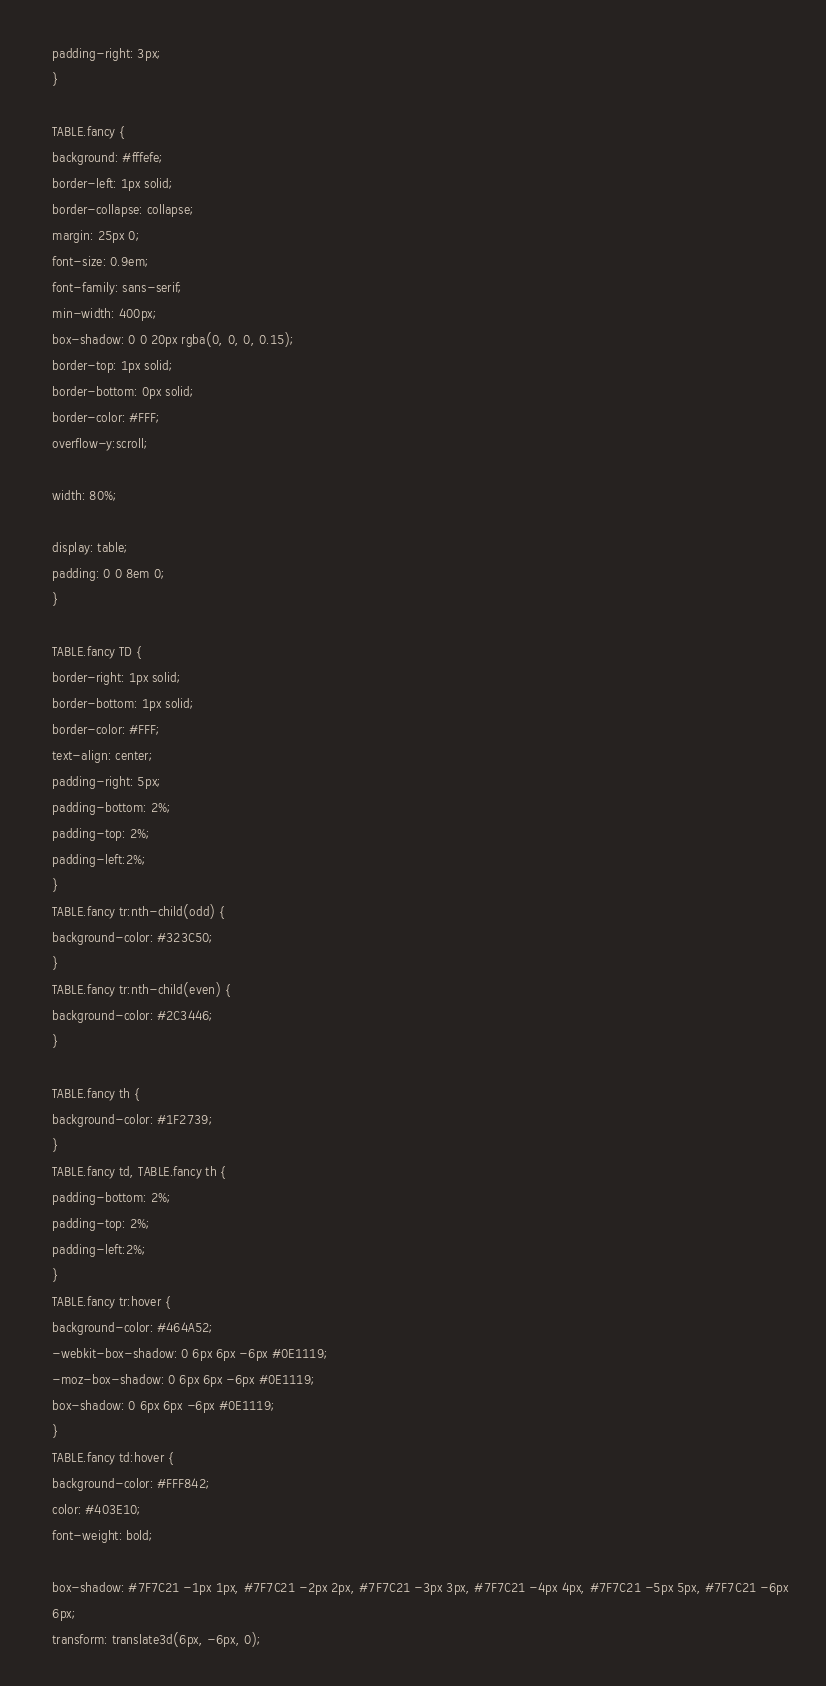<code> <loc_0><loc_0><loc_500><loc_500><_HTML_>    padding-right: 3px;
    }

    TABLE.fancy {
    background: #fffefe;
    border-left: 1px solid;
    border-collapse: collapse;
    margin: 25px 0;
    font-size: 0.9em;
    font-family: sans-serif;
    min-width: 400px;
    box-shadow: 0 0 20px rgba(0, 0, 0, 0.15);
    border-top: 1px solid;
    border-bottom: 0px solid;
    border-color: #FFF;
    overflow-y:scroll;

    width: 80%;

    display: table;
    padding: 0 0 8em 0;
    }

    TABLE.fancy TD {
    border-right: 1px solid;
    border-bottom: 1px solid;
    border-color: #FFF;
    text-align: center;
    padding-right: 5px;
    padding-bottom: 2%;
    padding-top: 2%;
    padding-left:2%;
    }
    TABLE.fancy tr:nth-child(odd) {
    background-color: #323C50;
    }
    TABLE.fancy tr:nth-child(even) {
    background-color: #2C3446;
    }

    TABLE.fancy th {
    background-color: #1F2739;
    }
    TABLE.fancy td, TABLE.fancy th {
    padding-bottom: 2%;
    padding-top: 2%;
    padding-left:2%;
    }
    TABLE.fancy tr:hover {
    background-color: #464A52;
    -webkit-box-shadow: 0 6px 6px -6px #0E1119;
    -moz-box-shadow: 0 6px 6px -6px #0E1119;
    box-shadow: 0 6px 6px -6px #0E1119;
    }
    TABLE.fancy td:hover {
    background-color: #FFF842;
    color: #403E10;
    font-weight: bold;

    box-shadow: #7F7C21 -1px 1px, #7F7C21 -2px 2px, #7F7C21 -3px 3px, #7F7C21 -4px 4px, #7F7C21 -5px 5px, #7F7C21 -6px
    6px;
    transform: translate3d(6px, -6px, 0);
</code> 